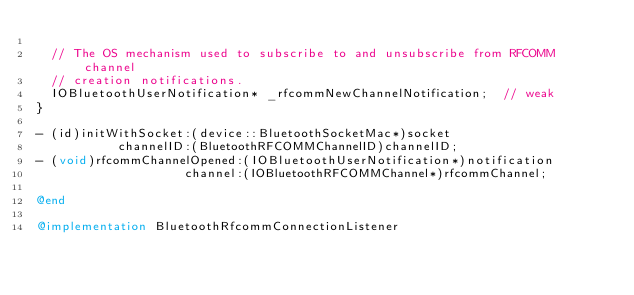<code> <loc_0><loc_0><loc_500><loc_500><_ObjectiveC_>
  // The OS mechanism used to subscribe to and unsubscribe from RFCOMM channel
  // creation notifications.
  IOBluetoothUserNotification* _rfcommNewChannelNotification;  // weak
}

- (id)initWithSocket:(device::BluetoothSocketMac*)socket
           channelID:(BluetoothRFCOMMChannelID)channelID;
- (void)rfcommChannelOpened:(IOBluetoothUserNotification*)notification
                    channel:(IOBluetoothRFCOMMChannel*)rfcommChannel;

@end

@implementation BluetoothRfcommConnectionListener
</code> 